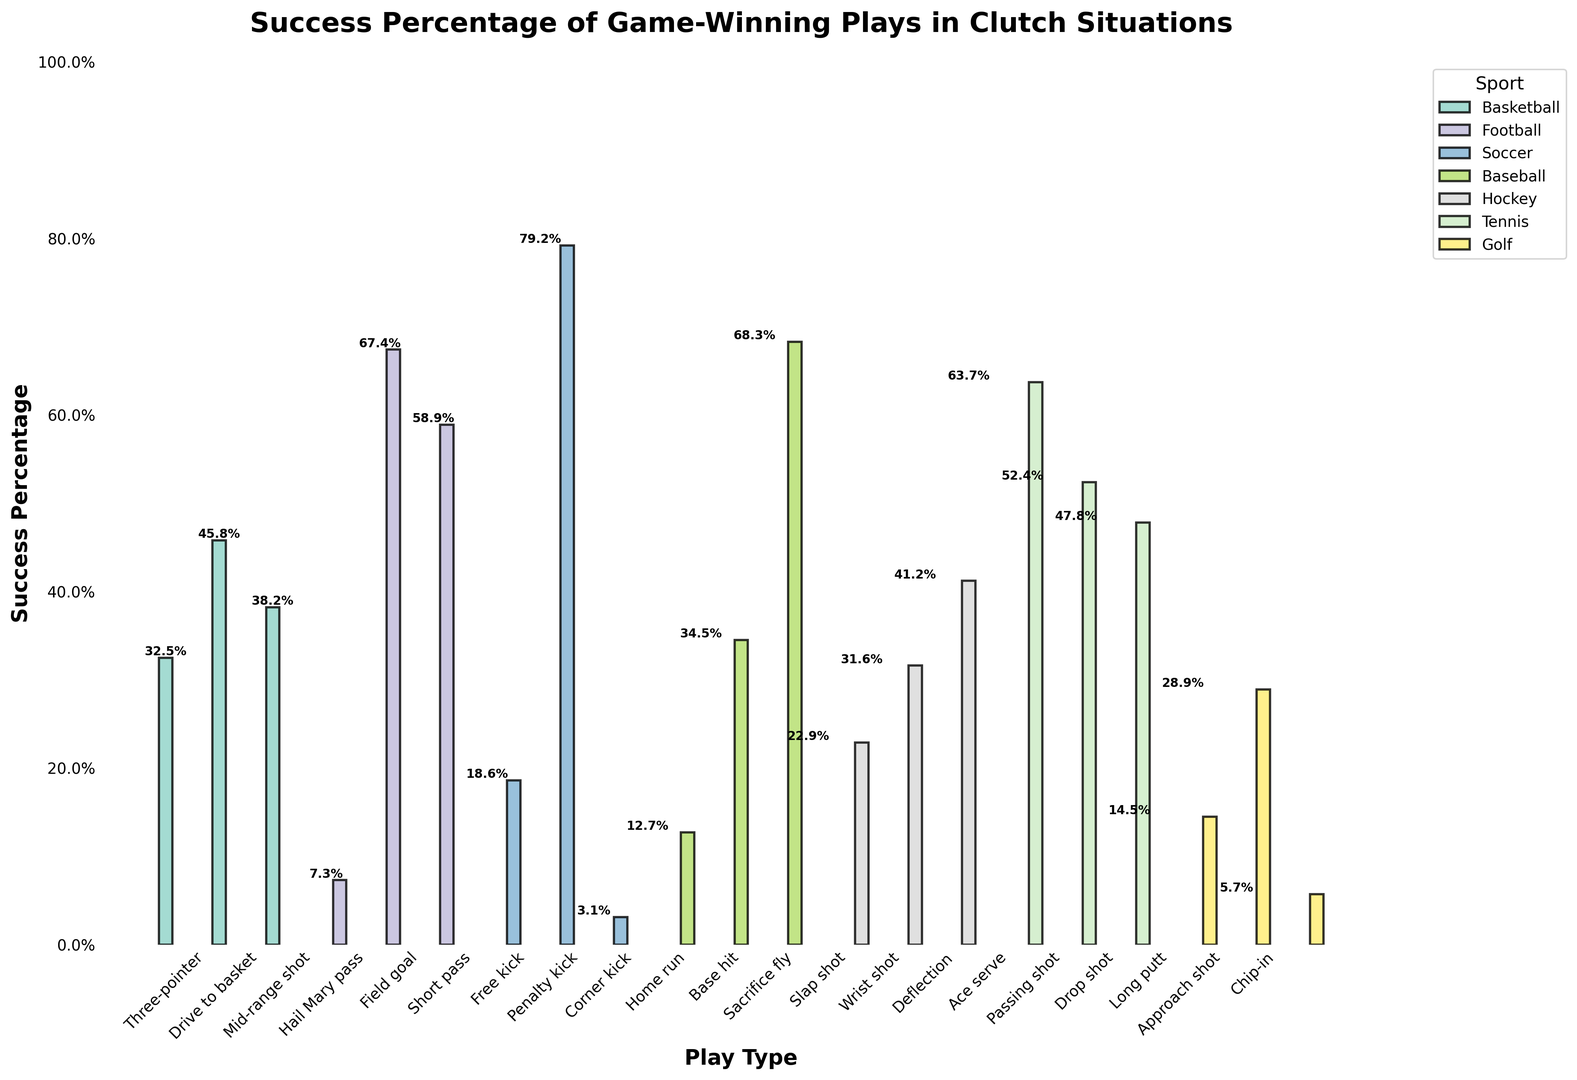Which play type in Soccer has the lowest success percentage? Look for the lowest bar in the Soccer category. The Corner kick play type in Soccer has a success percentage of 3.1%, which is the lowest.
Answer: Corner kick Which sport has the highest average success percentage for game-winning plays? Calculate the average success percentage for each sport. Football has percentages of 7.3, 67.4, and 58.9. Their sum is 133.6, and the average is 133.6/3 = 44.53. Similarly, perform for all sports, and Soccer, with percentages of 18.6, 79.2, and 3.1, sum 100.9, average 33.63. Basketball with 32.5, 45.8, and 38.2, sum 116.5, average 38.83, Baseball with 12.7, 34.5, and 68.3, sum 115.5, average 38.5, Hockey with 22.9, 31.6, and 41.2, sum 95.7, average 31.9, Tennis with 63.7, 52.4, and 47.8, sum 163.9, average 54.63, and Golf with 14.5, 28.9, and 5.7, sum 49.1, average 16.37. Tennis has the highest average.
Answer: Tennis Which play type across all sports has the highest success percentage? Identify the bar with the highest value. Penalty kick in Soccer has the highest success percentage of 79.2%.
Answer: Penalty kick How does the success percentage of a field goal in Football compare to a free kick in Soccer? Observe the relative heights of the bars. Field goal in Football has a success percentage of 67.4%, while a free kick in Soccer has 18.6%.
Answer: Football Field Goal is higher What is the combined success percentage of Basketball's Drive to basket and Mid-range shot? Add the percentages of Drive to basket and Mid-range shot. They are 45.8% and 38.2%, respectively. The combined success percentage is 45.8 + 38.2 = 84%.
Answer: 84% What is the difference between the success percentages of a Baseball Home run and a Baseball Sacrifice fly? Subtract the smaller percentage from the larger percentage. The percentages are 12.7% and 68.3%, respectively. The difference is 68.3 - 12.7 = 55.6%.
Answer: 55.6% Which play type in Tennis has the least success percentage and what is it? Find the lowest bar in the Tennis category. The Drop shot has the least success percentage at 47.8%.
Answer: Drop shot, 47.8% On average, how successful are the plays in Hockey? Calculate the average of the percentages for Hockey. These are 22.9, 31.6, and 41.2. Their sum is 95.7, and the average is 95.7/3 = 31.9%.
Answer: 31.9% In Basketball, which play type has the highest success percentage, and what is it? Identify the highest bar in the Basketball category. Drive to basket has the highest success percentage of 45.8%.
Answer: Drive to basket, 45.8% Is the success percentage of a Golf Chip-in higher or lower than a Soccer Free kick, and by how much? Compare the bars for Golf Chip-in and Soccer Free kick. Chip-in has 5.7% and Free kick has 18.6%. Subtract to find the difference. 18.6 - 5.7 = 12.9%.
Answer: Lower by 12.9% 